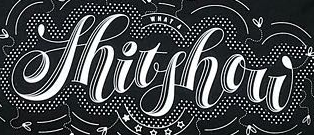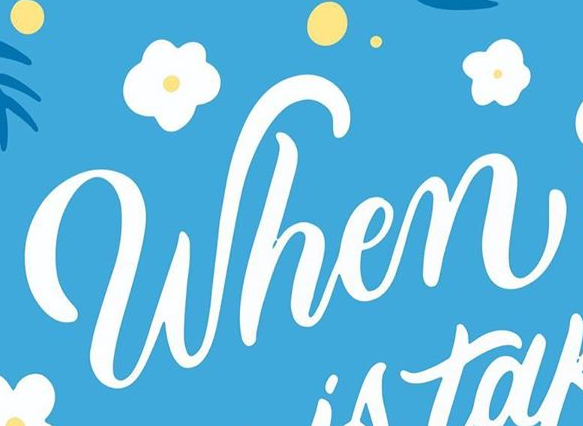Read the text content from these images in order, separated by a semicolon. Shitshow; When 